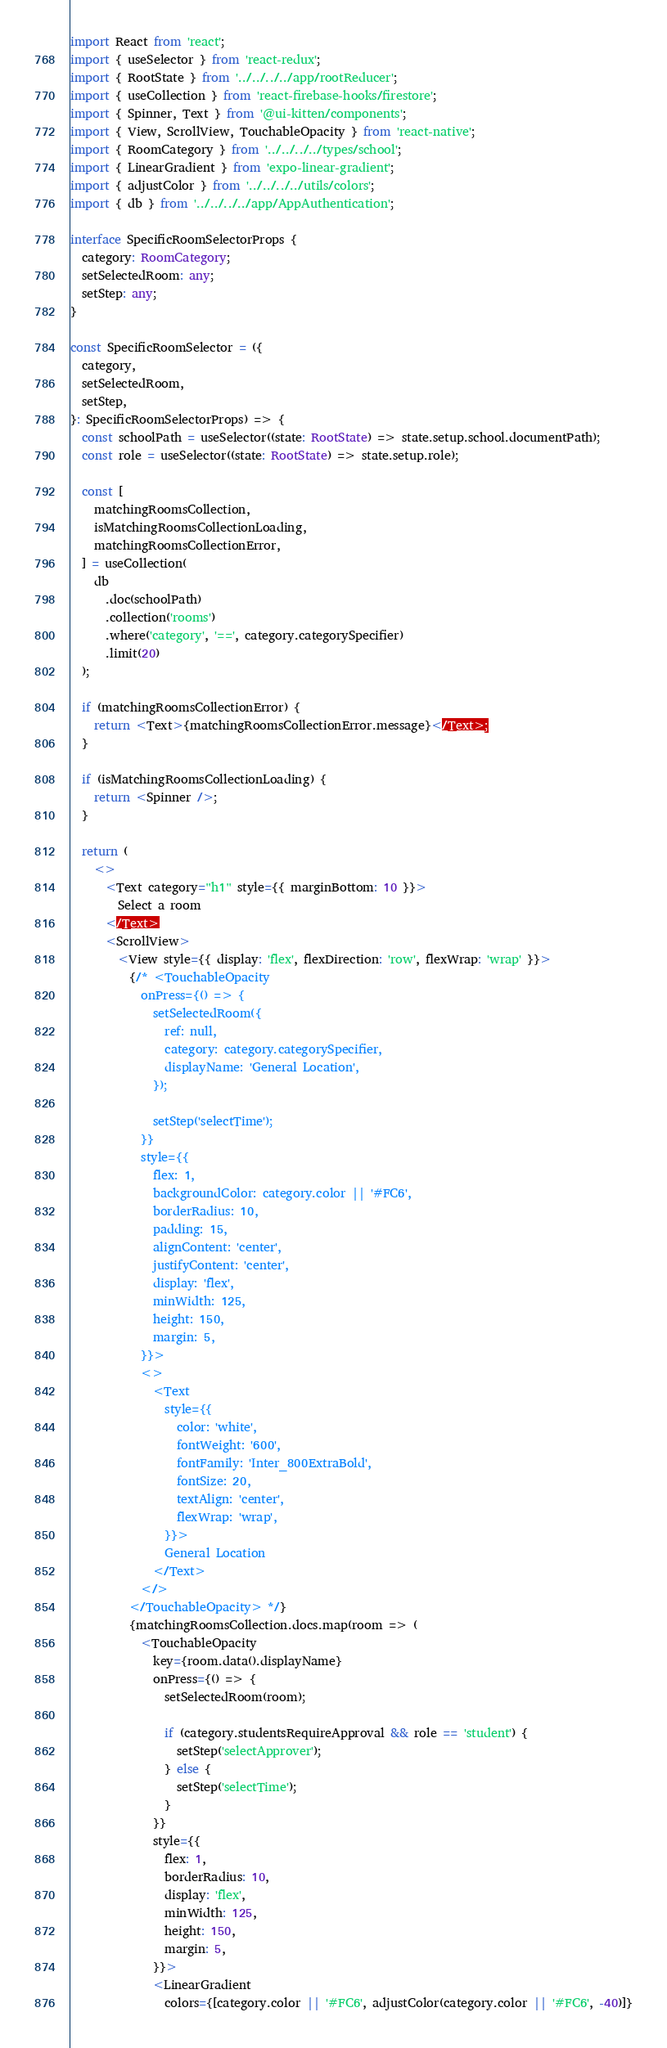Convert code to text. <code><loc_0><loc_0><loc_500><loc_500><_TypeScript_>import React from 'react';
import { useSelector } from 'react-redux';
import { RootState } from '../../../../app/rootReducer';
import { useCollection } from 'react-firebase-hooks/firestore';
import { Spinner, Text } from '@ui-kitten/components';
import { View, ScrollView, TouchableOpacity } from 'react-native';
import { RoomCategory } from '../../../../types/school';
import { LinearGradient } from 'expo-linear-gradient';
import { adjustColor } from '../../../../utils/colors';
import { db } from '../../../../app/AppAuthentication';

interface SpecificRoomSelectorProps {
  category: RoomCategory;
  setSelectedRoom: any;
  setStep: any;
}

const SpecificRoomSelector = ({
  category,
  setSelectedRoom,
  setStep,
}: SpecificRoomSelectorProps) => {
  const schoolPath = useSelector((state: RootState) => state.setup.school.documentPath);
  const role = useSelector((state: RootState) => state.setup.role);

  const [
    matchingRoomsCollection,
    isMatchingRoomsCollectionLoading,
    matchingRoomsCollectionError,
  ] = useCollection(
    db
      .doc(schoolPath)
      .collection('rooms')
      .where('category', '==', category.categorySpecifier)
      .limit(20)
  );

  if (matchingRoomsCollectionError) {
    return <Text>{matchingRoomsCollectionError.message}</Text>;
  }

  if (isMatchingRoomsCollectionLoading) {
    return <Spinner />;
  }

  return (
    <>
      <Text category="h1" style={{ marginBottom: 10 }}>
        Select a room
      </Text>
      <ScrollView>
        <View style={{ display: 'flex', flexDirection: 'row', flexWrap: 'wrap' }}>
          {/* <TouchableOpacity
            onPress={() => {
              setSelectedRoom({
                ref: null,
                category: category.categorySpecifier,
                displayName: 'General Location',
              });

              setStep('selectTime');
            }}
            style={{
              flex: 1,
              backgroundColor: category.color || '#FC6',
              borderRadius: 10,
              padding: 15,
              alignContent: 'center',
              justifyContent: 'center',
              display: 'flex',
              minWidth: 125,
              height: 150,
              margin: 5,
            }}>
            <>
              <Text
                style={{
                  color: 'white',
                  fontWeight: '600',
                  fontFamily: 'Inter_800ExtraBold',
                  fontSize: 20,
                  textAlign: 'center',
                  flexWrap: 'wrap',
                }}>
                General Location
              </Text>
            </>
          </TouchableOpacity> */}
          {matchingRoomsCollection.docs.map(room => (
            <TouchableOpacity
              key={room.data().displayName}
              onPress={() => {
                setSelectedRoom(room);

                if (category.studentsRequireApproval && role == 'student') {
                  setStep('selectApprover');
                } else {
                  setStep('selectTime');
                }
              }}
              style={{
                flex: 1,
                borderRadius: 10,
                display: 'flex',
                minWidth: 125,
                height: 150,
                margin: 5,
              }}>
              <LinearGradient
                colors={[category.color || '#FC6', adjustColor(category.color || '#FC6', -40)]}</code> 